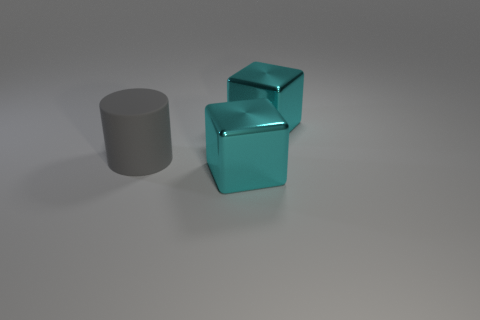Subtract all red cylinders. Subtract all cyan spheres. How many cylinders are left? 1 Add 3 big cyan cubes. How many objects exist? 6 Subtract all cubes. How many objects are left? 1 Subtract all brown blocks. Subtract all big gray rubber cylinders. How many objects are left? 2 Add 3 big gray matte objects. How many big gray matte objects are left? 4 Add 1 cylinders. How many cylinders exist? 2 Subtract 0 blue cylinders. How many objects are left? 3 